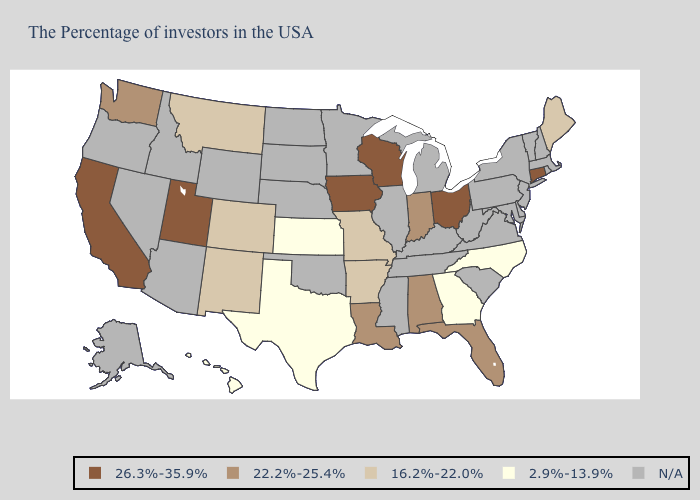Name the states that have a value in the range 22.2%-25.4%?
Be succinct. Florida, Indiana, Alabama, Louisiana, Washington. What is the lowest value in states that border New York?
Give a very brief answer. 26.3%-35.9%. What is the value of Alabama?
Keep it brief. 22.2%-25.4%. Name the states that have a value in the range 26.3%-35.9%?
Keep it brief. Connecticut, Ohio, Wisconsin, Iowa, Utah, California. What is the value of New Mexico?
Keep it brief. 16.2%-22.0%. Name the states that have a value in the range 26.3%-35.9%?
Concise answer only. Connecticut, Ohio, Wisconsin, Iowa, Utah, California. What is the value of South Dakota?
Write a very short answer. N/A. What is the value of Oregon?
Write a very short answer. N/A. Name the states that have a value in the range 16.2%-22.0%?
Write a very short answer. Maine, Missouri, Arkansas, Colorado, New Mexico, Montana. Name the states that have a value in the range 2.9%-13.9%?
Answer briefly. North Carolina, Georgia, Kansas, Texas, Hawaii. Which states have the lowest value in the South?
Write a very short answer. North Carolina, Georgia, Texas. What is the lowest value in the Northeast?
Write a very short answer. 16.2%-22.0%. Name the states that have a value in the range 16.2%-22.0%?
Keep it brief. Maine, Missouri, Arkansas, Colorado, New Mexico, Montana. 